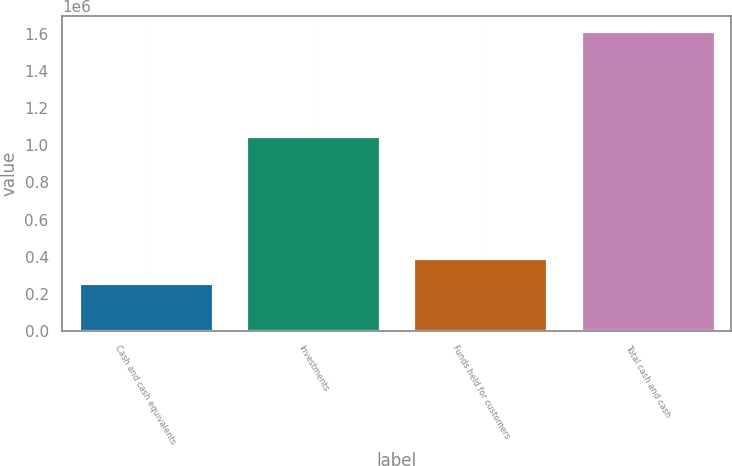<chart> <loc_0><loc_0><loc_500><loc_500><bar_chart><fcel>Cash and cash equivalents<fcel>Investments<fcel>Funds held for customers<fcel>Total cash and cash<nl><fcel>255201<fcel>1.04864e+06<fcel>391499<fcel>1.61818e+06<nl></chart> 